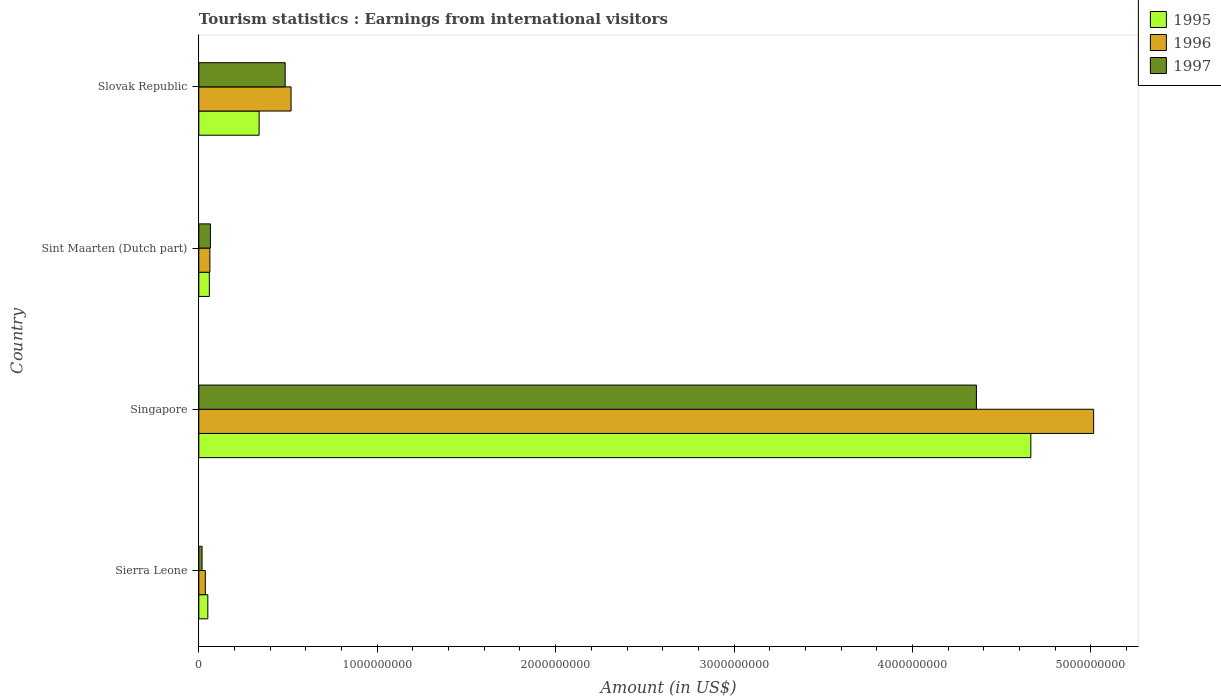How many groups of bars are there?
Your response must be concise. 4. Are the number of bars per tick equal to the number of legend labels?
Ensure brevity in your answer.  Yes. Are the number of bars on each tick of the Y-axis equal?
Ensure brevity in your answer.  Yes. How many bars are there on the 2nd tick from the bottom?
Your answer should be very brief. 3. What is the label of the 4th group of bars from the top?
Provide a succinct answer. Sierra Leone. In how many cases, is the number of bars for a given country not equal to the number of legend labels?
Make the answer very short. 0. What is the earnings from international visitors in 1995 in Singapore?
Offer a terse response. 4.66e+09. Across all countries, what is the maximum earnings from international visitors in 1997?
Offer a very short reply. 4.36e+09. Across all countries, what is the minimum earnings from international visitors in 1995?
Your answer should be compact. 5.05e+07. In which country was the earnings from international visitors in 1997 maximum?
Provide a short and direct response. Singapore. In which country was the earnings from international visitors in 1996 minimum?
Give a very brief answer. Sierra Leone. What is the total earnings from international visitors in 1997 in the graph?
Provide a succinct answer. 4.93e+09. What is the difference between the earnings from international visitors in 1997 in Singapore and that in Slovak Republic?
Provide a succinct answer. 3.87e+09. What is the difference between the earnings from international visitors in 1996 in Sierra Leone and the earnings from international visitors in 1997 in Slovak Republic?
Ensure brevity in your answer.  -4.48e+08. What is the average earnings from international visitors in 1995 per country?
Make the answer very short. 1.28e+09. What is the difference between the earnings from international visitors in 1996 and earnings from international visitors in 1995 in Sierra Leone?
Make the answer very short. -1.40e+07. In how many countries, is the earnings from international visitors in 1997 greater than 1600000000 US$?
Ensure brevity in your answer.  1. What is the ratio of the earnings from international visitors in 1995 in Singapore to that in Slovak Republic?
Make the answer very short. 13.8. What is the difference between the highest and the second highest earnings from international visitors in 1995?
Your response must be concise. 4.32e+09. What is the difference between the highest and the lowest earnings from international visitors in 1996?
Offer a very short reply. 4.98e+09. In how many countries, is the earnings from international visitors in 1997 greater than the average earnings from international visitors in 1997 taken over all countries?
Ensure brevity in your answer.  1. Is the sum of the earnings from international visitors in 1995 in Sierra Leone and Sint Maarten (Dutch part) greater than the maximum earnings from international visitors in 1997 across all countries?
Your answer should be compact. No. What does the 3rd bar from the top in Slovak Republic represents?
Provide a succinct answer. 1995. What does the 3rd bar from the bottom in Sierra Leone represents?
Make the answer very short. 1997. Are all the bars in the graph horizontal?
Your answer should be compact. Yes. How many countries are there in the graph?
Ensure brevity in your answer.  4. What is the difference between two consecutive major ticks on the X-axis?
Make the answer very short. 1.00e+09. Are the values on the major ticks of X-axis written in scientific E-notation?
Offer a very short reply. No. Does the graph contain any zero values?
Make the answer very short. No. Does the graph contain grids?
Ensure brevity in your answer.  No. How are the legend labels stacked?
Offer a terse response. Vertical. What is the title of the graph?
Keep it short and to the point. Tourism statistics : Earnings from international visitors. Does "1960" appear as one of the legend labels in the graph?
Your answer should be very brief. No. What is the label or title of the X-axis?
Offer a very short reply. Amount (in US$). What is the Amount (in US$) in 1995 in Sierra Leone?
Ensure brevity in your answer.  5.05e+07. What is the Amount (in US$) in 1996 in Sierra Leone?
Give a very brief answer. 3.65e+07. What is the Amount (in US$) in 1997 in Sierra Leone?
Give a very brief answer. 1.81e+07. What is the Amount (in US$) in 1995 in Singapore?
Your response must be concise. 4.66e+09. What is the Amount (in US$) in 1996 in Singapore?
Your answer should be compact. 5.02e+09. What is the Amount (in US$) in 1997 in Singapore?
Offer a very short reply. 4.36e+09. What is the Amount (in US$) of 1995 in Sint Maarten (Dutch part)?
Provide a short and direct response. 5.90e+07. What is the Amount (in US$) in 1996 in Sint Maarten (Dutch part)?
Provide a succinct answer. 6.20e+07. What is the Amount (in US$) of 1997 in Sint Maarten (Dutch part)?
Your answer should be very brief. 6.50e+07. What is the Amount (in US$) of 1995 in Slovak Republic?
Ensure brevity in your answer.  3.38e+08. What is the Amount (in US$) in 1996 in Slovak Republic?
Offer a terse response. 5.17e+08. What is the Amount (in US$) of 1997 in Slovak Republic?
Provide a short and direct response. 4.84e+08. Across all countries, what is the maximum Amount (in US$) in 1995?
Give a very brief answer. 4.66e+09. Across all countries, what is the maximum Amount (in US$) of 1996?
Make the answer very short. 5.02e+09. Across all countries, what is the maximum Amount (in US$) in 1997?
Provide a short and direct response. 4.36e+09. Across all countries, what is the minimum Amount (in US$) in 1995?
Ensure brevity in your answer.  5.05e+07. Across all countries, what is the minimum Amount (in US$) in 1996?
Provide a short and direct response. 3.65e+07. Across all countries, what is the minimum Amount (in US$) of 1997?
Your answer should be compact. 1.81e+07. What is the total Amount (in US$) in 1995 in the graph?
Keep it short and to the point. 5.11e+09. What is the total Amount (in US$) of 1996 in the graph?
Make the answer very short. 5.63e+09. What is the total Amount (in US$) in 1997 in the graph?
Offer a very short reply. 4.93e+09. What is the difference between the Amount (in US$) in 1995 in Sierra Leone and that in Singapore?
Offer a terse response. -4.61e+09. What is the difference between the Amount (in US$) in 1996 in Sierra Leone and that in Singapore?
Provide a short and direct response. -4.98e+09. What is the difference between the Amount (in US$) of 1997 in Sierra Leone and that in Singapore?
Keep it short and to the point. -4.34e+09. What is the difference between the Amount (in US$) of 1995 in Sierra Leone and that in Sint Maarten (Dutch part)?
Provide a short and direct response. -8.50e+06. What is the difference between the Amount (in US$) in 1996 in Sierra Leone and that in Sint Maarten (Dutch part)?
Offer a very short reply. -2.55e+07. What is the difference between the Amount (in US$) in 1997 in Sierra Leone and that in Sint Maarten (Dutch part)?
Your answer should be very brief. -4.69e+07. What is the difference between the Amount (in US$) in 1995 in Sierra Leone and that in Slovak Republic?
Your response must be concise. -2.88e+08. What is the difference between the Amount (in US$) of 1996 in Sierra Leone and that in Slovak Republic?
Ensure brevity in your answer.  -4.80e+08. What is the difference between the Amount (in US$) in 1997 in Sierra Leone and that in Slovak Republic?
Your response must be concise. -4.66e+08. What is the difference between the Amount (in US$) of 1995 in Singapore and that in Sint Maarten (Dutch part)?
Provide a short and direct response. 4.60e+09. What is the difference between the Amount (in US$) in 1996 in Singapore and that in Sint Maarten (Dutch part)?
Keep it short and to the point. 4.95e+09. What is the difference between the Amount (in US$) of 1997 in Singapore and that in Sint Maarten (Dutch part)?
Your answer should be compact. 4.29e+09. What is the difference between the Amount (in US$) in 1995 in Singapore and that in Slovak Republic?
Provide a succinct answer. 4.32e+09. What is the difference between the Amount (in US$) in 1996 in Singapore and that in Slovak Republic?
Keep it short and to the point. 4.50e+09. What is the difference between the Amount (in US$) in 1997 in Singapore and that in Slovak Republic?
Provide a short and direct response. 3.87e+09. What is the difference between the Amount (in US$) in 1995 in Sint Maarten (Dutch part) and that in Slovak Republic?
Give a very brief answer. -2.79e+08. What is the difference between the Amount (in US$) of 1996 in Sint Maarten (Dutch part) and that in Slovak Republic?
Your response must be concise. -4.55e+08. What is the difference between the Amount (in US$) in 1997 in Sint Maarten (Dutch part) and that in Slovak Republic?
Provide a short and direct response. -4.19e+08. What is the difference between the Amount (in US$) in 1995 in Sierra Leone and the Amount (in US$) in 1996 in Singapore?
Your answer should be very brief. -4.96e+09. What is the difference between the Amount (in US$) of 1995 in Sierra Leone and the Amount (in US$) of 1997 in Singapore?
Provide a succinct answer. -4.31e+09. What is the difference between the Amount (in US$) of 1996 in Sierra Leone and the Amount (in US$) of 1997 in Singapore?
Give a very brief answer. -4.32e+09. What is the difference between the Amount (in US$) in 1995 in Sierra Leone and the Amount (in US$) in 1996 in Sint Maarten (Dutch part)?
Give a very brief answer. -1.15e+07. What is the difference between the Amount (in US$) in 1995 in Sierra Leone and the Amount (in US$) in 1997 in Sint Maarten (Dutch part)?
Provide a short and direct response. -1.45e+07. What is the difference between the Amount (in US$) in 1996 in Sierra Leone and the Amount (in US$) in 1997 in Sint Maarten (Dutch part)?
Offer a very short reply. -2.85e+07. What is the difference between the Amount (in US$) of 1995 in Sierra Leone and the Amount (in US$) of 1996 in Slovak Republic?
Offer a very short reply. -4.66e+08. What is the difference between the Amount (in US$) of 1995 in Sierra Leone and the Amount (in US$) of 1997 in Slovak Republic?
Offer a very short reply. -4.34e+08. What is the difference between the Amount (in US$) in 1996 in Sierra Leone and the Amount (in US$) in 1997 in Slovak Republic?
Make the answer very short. -4.48e+08. What is the difference between the Amount (in US$) in 1995 in Singapore and the Amount (in US$) in 1996 in Sint Maarten (Dutch part)?
Provide a succinct answer. 4.60e+09. What is the difference between the Amount (in US$) of 1995 in Singapore and the Amount (in US$) of 1997 in Sint Maarten (Dutch part)?
Provide a short and direct response. 4.60e+09. What is the difference between the Amount (in US$) of 1996 in Singapore and the Amount (in US$) of 1997 in Sint Maarten (Dutch part)?
Provide a short and direct response. 4.95e+09. What is the difference between the Amount (in US$) in 1995 in Singapore and the Amount (in US$) in 1996 in Slovak Republic?
Ensure brevity in your answer.  4.15e+09. What is the difference between the Amount (in US$) of 1995 in Singapore and the Amount (in US$) of 1997 in Slovak Republic?
Keep it short and to the point. 4.18e+09. What is the difference between the Amount (in US$) in 1996 in Singapore and the Amount (in US$) in 1997 in Slovak Republic?
Offer a terse response. 4.53e+09. What is the difference between the Amount (in US$) of 1995 in Sint Maarten (Dutch part) and the Amount (in US$) of 1996 in Slovak Republic?
Offer a very short reply. -4.58e+08. What is the difference between the Amount (in US$) in 1995 in Sint Maarten (Dutch part) and the Amount (in US$) in 1997 in Slovak Republic?
Make the answer very short. -4.25e+08. What is the difference between the Amount (in US$) of 1996 in Sint Maarten (Dutch part) and the Amount (in US$) of 1997 in Slovak Republic?
Provide a succinct answer. -4.22e+08. What is the average Amount (in US$) of 1995 per country?
Your answer should be compact. 1.28e+09. What is the average Amount (in US$) of 1996 per country?
Give a very brief answer. 1.41e+09. What is the average Amount (in US$) in 1997 per country?
Your answer should be very brief. 1.23e+09. What is the difference between the Amount (in US$) of 1995 and Amount (in US$) of 1996 in Sierra Leone?
Provide a short and direct response. 1.40e+07. What is the difference between the Amount (in US$) in 1995 and Amount (in US$) in 1997 in Sierra Leone?
Your answer should be very brief. 3.24e+07. What is the difference between the Amount (in US$) in 1996 and Amount (in US$) in 1997 in Sierra Leone?
Your answer should be compact. 1.84e+07. What is the difference between the Amount (in US$) of 1995 and Amount (in US$) of 1996 in Singapore?
Your answer should be compact. -3.52e+08. What is the difference between the Amount (in US$) in 1995 and Amount (in US$) in 1997 in Singapore?
Keep it short and to the point. 3.05e+08. What is the difference between the Amount (in US$) of 1996 and Amount (in US$) of 1997 in Singapore?
Give a very brief answer. 6.57e+08. What is the difference between the Amount (in US$) in 1995 and Amount (in US$) in 1997 in Sint Maarten (Dutch part)?
Ensure brevity in your answer.  -6.00e+06. What is the difference between the Amount (in US$) in 1996 and Amount (in US$) in 1997 in Sint Maarten (Dutch part)?
Provide a short and direct response. -3.00e+06. What is the difference between the Amount (in US$) in 1995 and Amount (in US$) in 1996 in Slovak Republic?
Provide a succinct answer. -1.79e+08. What is the difference between the Amount (in US$) in 1995 and Amount (in US$) in 1997 in Slovak Republic?
Your answer should be compact. -1.46e+08. What is the difference between the Amount (in US$) of 1996 and Amount (in US$) of 1997 in Slovak Republic?
Keep it short and to the point. 3.30e+07. What is the ratio of the Amount (in US$) of 1995 in Sierra Leone to that in Singapore?
Offer a terse response. 0.01. What is the ratio of the Amount (in US$) of 1996 in Sierra Leone to that in Singapore?
Ensure brevity in your answer.  0.01. What is the ratio of the Amount (in US$) in 1997 in Sierra Leone to that in Singapore?
Your answer should be compact. 0. What is the ratio of the Amount (in US$) in 1995 in Sierra Leone to that in Sint Maarten (Dutch part)?
Give a very brief answer. 0.86. What is the ratio of the Amount (in US$) in 1996 in Sierra Leone to that in Sint Maarten (Dutch part)?
Keep it short and to the point. 0.59. What is the ratio of the Amount (in US$) in 1997 in Sierra Leone to that in Sint Maarten (Dutch part)?
Make the answer very short. 0.28. What is the ratio of the Amount (in US$) in 1995 in Sierra Leone to that in Slovak Republic?
Offer a very short reply. 0.15. What is the ratio of the Amount (in US$) in 1996 in Sierra Leone to that in Slovak Republic?
Your response must be concise. 0.07. What is the ratio of the Amount (in US$) in 1997 in Sierra Leone to that in Slovak Republic?
Provide a short and direct response. 0.04. What is the ratio of the Amount (in US$) in 1995 in Singapore to that in Sint Maarten (Dutch part)?
Offer a terse response. 79.03. What is the ratio of the Amount (in US$) in 1996 in Singapore to that in Sint Maarten (Dutch part)?
Keep it short and to the point. 80.89. What is the ratio of the Amount (in US$) of 1997 in Singapore to that in Sint Maarten (Dutch part)?
Give a very brief answer. 67.05. What is the ratio of the Amount (in US$) of 1995 in Singapore to that in Slovak Republic?
Give a very brief answer. 13.8. What is the ratio of the Amount (in US$) of 1996 in Singapore to that in Slovak Republic?
Keep it short and to the point. 9.7. What is the ratio of the Amount (in US$) in 1997 in Singapore to that in Slovak Republic?
Your answer should be compact. 9. What is the ratio of the Amount (in US$) in 1995 in Sint Maarten (Dutch part) to that in Slovak Republic?
Ensure brevity in your answer.  0.17. What is the ratio of the Amount (in US$) in 1996 in Sint Maarten (Dutch part) to that in Slovak Republic?
Provide a short and direct response. 0.12. What is the ratio of the Amount (in US$) in 1997 in Sint Maarten (Dutch part) to that in Slovak Republic?
Keep it short and to the point. 0.13. What is the difference between the highest and the second highest Amount (in US$) of 1995?
Your answer should be very brief. 4.32e+09. What is the difference between the highest and the second highest Amount (in US$) in 1996?
Provide a succinct answer. 4.50e+09. What is the difference between the highest and the second highest Amount (in US$) of 1997?
Your answer should be compact. 3.87e+09. What is the difference between the highest and the lowest Amount (in US$) in 1995?
Your answer should be compact. 4.61e+09. What is the difference between the highest and the lowest Amount (in US$) of 1996?
Your response must be concise. 4.98e+09. What is the difference between the highest and the lowest Amount (in US$) in 1997?
Your answer should be very brief. 4.34e+09. 